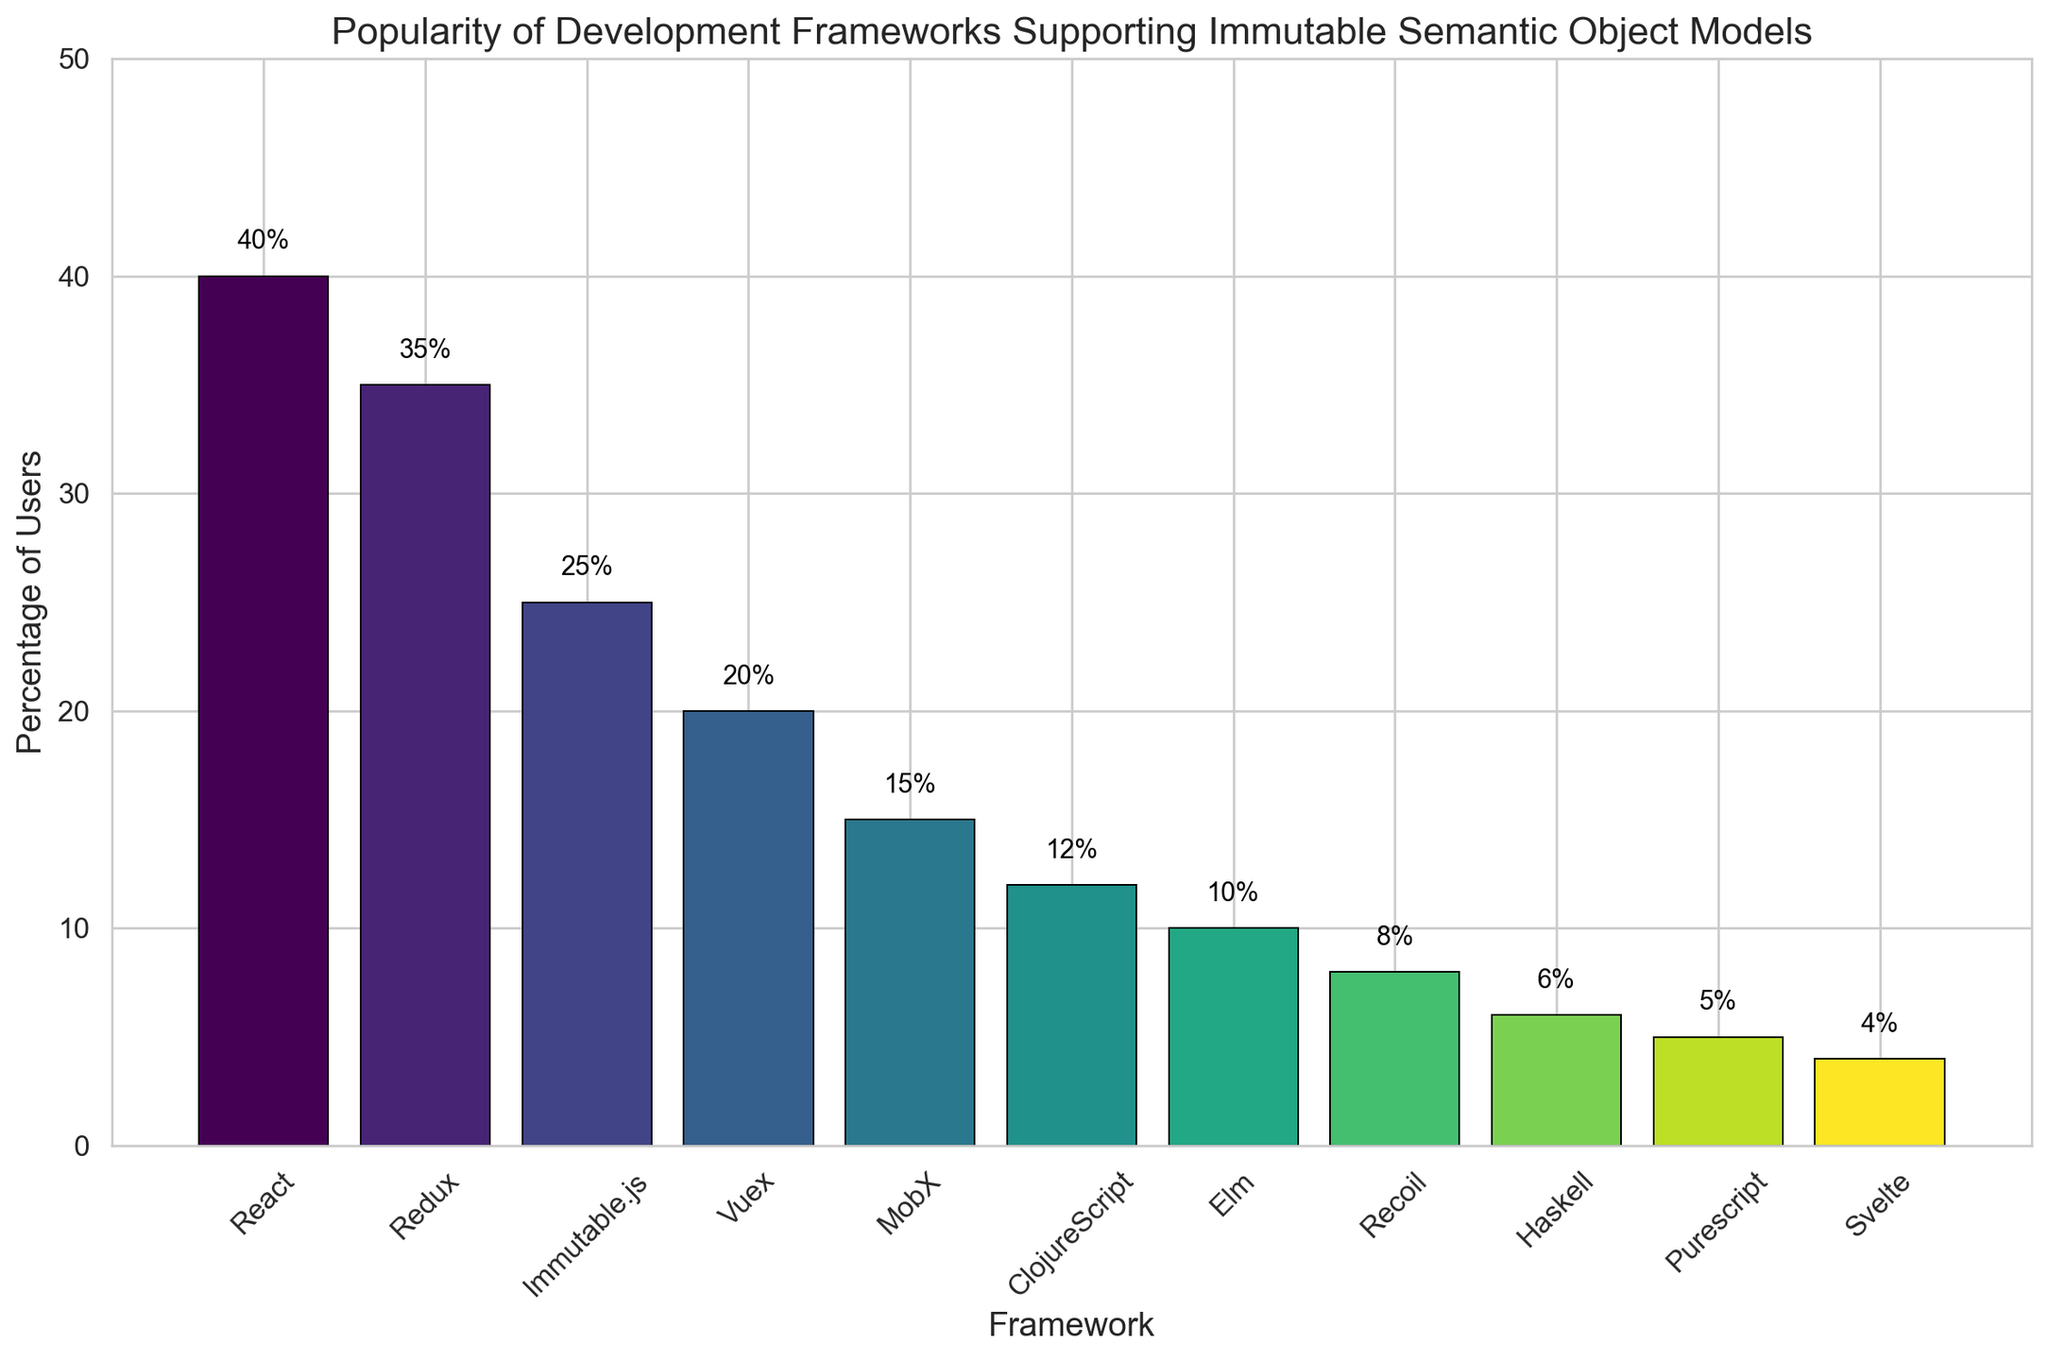Which framework is the most popular? The highest bar in the figure represents the framework with the highest percentage of users. React has the tallest bar.
Answer: React What percentage of users prefer React over Redux? React has a percentage of 40%, while Redux has 35%. Subtract Redux's percentage from React's to find the difference: 40% - 35% = 5%.
Answer: 5% Which frameworks have less than 10% of users? Identify the bars with heights representing less than 10%. Recoil, Haskell, Purescript, and Svelte have percentages of 8%, 6%, 5%, and 4% respectively.
Answer: Recoil, Haskell, Purescript, Svelte How many frameworks have a user percentage between 10% and 20%? Count the bars with heights between the 10% and 20% marks. MobX, ClojureScript, and Elm fall within this range.
Answer: 3 What is the combined user percentage for Immutable.js and Vuex? Find the percentages for both frameworks and add them together: 25% (Immutable.js) + 20% (Vuex) = 45%.
Answer: 45% Is the percentage of users for Elm higher than for Recoil? Compare the heights of the bars for Elm and Recoil. Elm has 10% and Recoil has 8%. Hence, Elm is higher.
Answer: Yes By how much does React's popularity exceed the average popularity of all listed frameworks? First, calculate the average: (40 + 35 + 25 + 20 + 15 + 12 + 10 + 8 + 6 + 5 + 4) / 11 ≈ 17.73%. Subtract this average from React's percentage: 40% - 17.73% ≈ 22.27%.
Answer: 22.27% What are the three least popular frameworks? Identify the three shortest bars. They correspond to Svelte (4%), Purescript (5%), and Haskell (6%).
Answer: Svelte, Purescript, Haskell Which framework is exactly 5 percentage points more popular than ClojureScript? ClojureScript has 12%, so add 5 to this: 12% + 5% = 17%. Now, check the bar values closest to 17%; there are none exactly at 17%, so no framework fits this criterion.
Answer: None What is the median user percentage of all the frameworks listed? Order the percentages: 4, 5, 6, 8, 10, 12, 15, 20, 25, 35, 40. The middle value (6th in an ordered list of 11 elements) corresponds to 12%. Hence, the median value is 12%.
Answer: 12% 